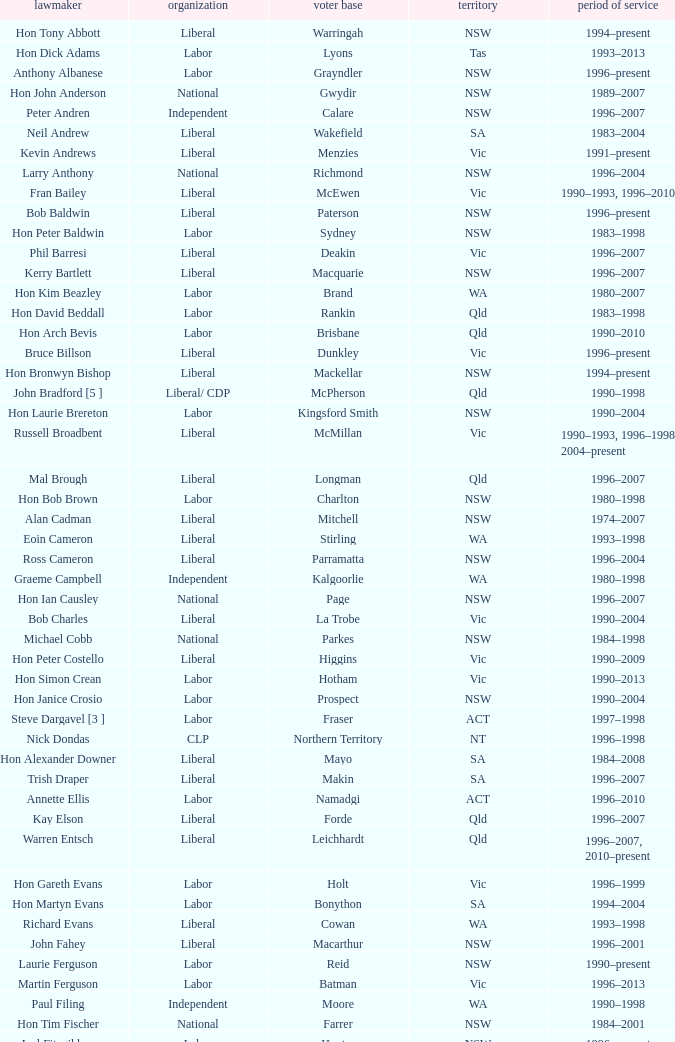Would you mind parsing the complete table? {'header': ['lawmaker', 'organization', 'voter base', 'territory', 'period of service'], 'rows': [['Hon Tony Abbott', 'Liberal', 'Warringah', 'NSW', '1994–present'], ['Hon Dick Adams', 'Labor', 'Lyons', 'Tas', '1993–2013'], ['Anthony Albanese', 'Labor', 'Grayndler', 'NSW', '1996–present'], ['Hon John Anderson', 'National', 'Gwydir', 'NSW', '1989–2007'], ['Peter Andren', 'Independent', 'Calare', 'NSW', '1996–2007'], ['Neil Andrew', 'Liberal', 'Wakefield', 'SA', '1983–2004'], ['Kevin Andrews', 'Liberal', 'Menzies', 'Vic', '1991–present'], ['Larry Anthony', 'National', 'Richmond', 'NSW', '1996–2004'], ['Fran Bailey', 'Liberal', 'McEwen', 'Vic', '1990–1993, 1996–2010'], ['Bob Baldwin', 'Liberal', 'Paterson', 'NSW', '1996–present'], ['Hon Peter Baldwin', 'Labor', 'Sydney', 'NSW', '1983–1998'], ['Phil Barresi', 'Liberal', 'Deakin', 'Vic', '1996–2007'], ['Kerry Bartlett', 'Liberal', 'Macquarie', 'NSW', '1996–2007'], ['Hon Kim Beazley', 'Labor', 'Brand', 'WA', '1980–2007'], ['Hon David Beddall', 'Labor', 'Rankin', 'Qld', '1983–1998'], ['Hon Arch Bevis', 'Labor', 'Brisbane', 'Qld', '1990–2010'], ['Bruce Billson', 'Liberal', 'Dunkley', 'Vic', '1996–present'], ['Hon Bronwyn Bishop', 'Liberal', 'Mackellar', 'NSW', '1994–present'], ['John Bradford [5 ]', 'Liberal/ CDP', 'McPherson', 'Qld', '1990–1998'], ['Hon Laurie Brereton', 'Labor', 'Kingsford Smith', 'NSW', '1990–2004'], ['Russell Broadbent', 'Liberal', 'McMillan', 'Vic', '1990–1993, 1996–1998 2004–present'], ['Mal Brough', 'Liberal', 'Longman', 'Qld', '1996–2007'], ['Hon Bob Brown', 'Labor', 'Charlton', 'NSW', '1980–1998'], ['Alan Cadman', 'Liberal', 'Mitchell', 'NSW', '1974–2007'], ['Eoin Cameron', 'Liberal', 'Stirling', 'WA', '1993–1998'], ['Ross Cameron', 'Liberal', 'Parramatta', 'NSW', '1996–2004'], ['Graeme Campbell', 'Independent', 'Kalgoorlie', 'WA', '1980–1998'], ['Hon Ian Causley', 'National', 'Page', 'NSW', '1996–2007'], ['Bob Charles', 'Liberal', 'La Trobe', 'Vic', '1990–2004'], ['Michael Cobb', 'National', 'Parkes', 'NSW', '1984–1998'], ['Hon Peter Costello', 'Liberal', 'Higgins', 'Vic', '1990–2009'], ['Hon Simon Crean', 'Labor', 'Hotham', 'Vic', '1990–2013'], ['Hon Janice Crosio', 'Labor', 'Prospect', 'NSW', '1990–2004'], ['Steve Dargavel [3 ]', 'Labor', 'Fraser', 'ACT', '1997–1998'], ['Nick Dondas', 'CLP', 'Northern Territory', 'NT', '1996–1998'], ['Hon Alexander Downer', 'Liberal', 'Mayo', 'SA', '1984–2008'], ['Trish Draper', 'Liberal', 'Makin', 'SA', '1996–2007'], ['Annette Ellis', 'Labor', 'Namadgi', 'ACT', '1996–2010'], ['Kay Elson', 'Liberal', 'Forde', 'Qld', '1996–2007'], ['Warren Entsch', 'Liberal', 'Leichhardt', 'Qld', '1996–2007, 2010–present'], ['Hon Gareth Evans', 'Labor', 'Holt', 'Vic', '1996–1999'], ['Hon Martyn Evans', 'Labor', 'Bonython', 'SA', '1994–2004'], ['Richard Evans', 'Liberal', 'Cowan', 'WA', '1993–1998'], ['John Fahey', 'Liberal', 'Macarthur', 'NSW', '1996–2001'], ['Laurie Ferguson', 'Labor', 'Reid', 'NSW', '1990–present'], ['Martin Ferguson', 'Labor', 'Batman', 'Vic', '1996–2013'], ['Paul Filing', 'Independent', 'Moore', 'WA', '1990–1998'], ['Hon Tim Fischer', 'National', 'Farrer', 'NSW', '1984–2001'], ['Joel Fitzgibbon', 'Labor', 'Hunter', 'NSW', '1996–present'], ['John Forrest', 'National', 'Mallee', 'Vic', '1993–2013'], ['Christine Gallus', 'Liberal', 'Hindmarsh', 'SA', '1990–2004'], ['Teresa Gambaro', 'Liberal', 'Petrie', 'Qld', '1996–2007, 2010–present'], ['Joanna Gash', 'Liberal', 'Gilmore', 'NSW', '1996–2013'], ['Petro Georgiou', 'Liberal', 'Kooyong', 'Vic', '1994–2010'], ['Ted Grace', 'Labor', 'Fowler', 'NSW', '1984–1998'], ['Elizabeth Grace', 'Liberal', 'Lilley', 'Qld', '1996–1998'], ['Alan Griffin', 'Labor', 'Bruce', 'Vic', '1993–present'], ['Bob Halverson', 'Liberal', 'Casey', 'Vic', '1984–1998'], ['Pauline Hanson [4 ]', 'Independent/ ONP', 'Oxley', 'Qld', '1996–1998'], ['Gary Hardgrave', 'Liberal', 'Moreton', 'Qld', '1996–2007'], ['Michael Hatton [1 ]', 'Labor', 'Blaxland', 'NSW', '1996–2007'], ['David Hawker', 'Liberal', 'Wannon', 'Vic', '1983–2010'], ['Noel Hicks', 'National', 'Riverina', 'NSW', '1980–1998'], ['Joe Hockey', 'Liberal', 'North Sydney', 'NSW', '1996–present'], ['Hon Clyde Holding', 'Labor', 'Melbourne Ports', 'Vic', '1977–1998'], ['Colin Hollis', 'Labor', 'Throsby', 'NSW', '1984–2001'], ['Hon John Howard', 'Liberal', 'Bennelong', 'NSW', '1974–2007'], ['Susan Jeanes', 'Liberal', 'Kingston', 'SA', '1996–1998'], ['Harry Jenkins', 'Labor', 'Scullin', 'Vic', '1986–2013'], ['Ricky Johnston', 'Liberal', 'Canning', 'WA', '1996–1998'], ['Hon Barry Jones', 'Labor', 'Lalor', 'Vic', '1977–1998'], ['Hon David Jull', 'Liberal', 'Fadden', 'Qld', '1975–1983, 1984–2007'], ['Hon Bob Katter', 'National', 'Kennedy', 'Qld', '1993–present'], ['Paul Keating [1 ]', 'Labor', 'Blaxland', 'NSW', '1969–1996'], ['De-Anne Kelly', 'National', 'Dawson', 'Qld', '1996–2007'], ['Jackie Kelly [2 ]', 'Liberal', 'Lindsay', 'NSW', '1996–2007'], ['Hon Dr David Kemp', 'Liberal', 'Goldstein', 'Vic', '1990–2004'], ['Hon Duncan Kerr', 'Labor', 'Denison', 'Tas', '1987–2010'], ['John Langmore [3 ]', 'Labor', 'Fraser', 'ACT', '1984–1997'], ['Mark Latham', 'Labor', 'Werriwa', 'NSW', '1994–2005'], ['Hon Dr Carmen Lawrence', 'Labor', 'Fremantle', 'WA', '1994–2007'], ['Hon Michael Lee', 'Labor', 'Dobell', 'NSW', '1984–2001'], ['Hon Lou Lieberman', 'Liberal', 'Indi', 'Vic', '1993–2001'], ['Peter Lindsay', 'Liberal', 'Herbert', 'Qld', '1996–2010'], ['Jim Lloyd', 'Liberal', 'Robertson', 'NSW', '1996–2007'], ['Stewart McArthur', 'Liberal', 'Corangamite', 'Vic', '1984–2007'], ['Robert McClelland', 'Labor', 'Barton', 'NSW', '1996–2013'], ['Graeme McDougall', 'Liberal', 'Griffith', 'Qld', '1996–1998'], ['Hon Peter McGauran', 'National', 'Gippsland', 'Vic', '1983–2008'], ['Hon Ian McLachlan', 'Liberal', 'Barker', 'SA', '1990–1998'], ['Hon Leo McLeay', 'Labor', 'Watson', 'NSW', '1979–2004'], ['Hon Bob McMullan', 'Labor', 'Canberra', 'ACT', '1996–2010'], ['Jenny Macklin', 'Labor', 'Jagajaga', 'Vic', '1996–present'], ['Paul Marek', 'National', 'Capricornia', 'Qld', '1996–1998'], ['Hon Stephen Martin', 'Labor', 'Cunningham', 'NSW', '1984–2002'], ['Daryl Melham', 'Labor', 'Banks', 'NSW', '1990–2013'], ['Hon Chris Miles', 'Liberal', 'Braddon', 'Tas', '1984–1998'], ['Hon John Moore', 'Liberal', 'Ryan', 'Qld', '1975–2001'], ['Allan Morris', 'Labor', 'Newcastle', 'NSW', '1983–2001'], ['Hon Peter Morris', 'Labor', 'Shortland', 'NSW', '1972–1998'], ['Frank Mossfield', 'Labor', 'Greenway', 'NSW', '1996–2004'], ['Hon Judi Moylan', 'Liberal', 'Pearce', 'WA', '1993–2013'], ['Stephen Mutch', 'Liberal', 'Cook', 'NSW', '1996–1998'], ['Gary Nairn', 'Liberal', 'Eden-Monaro', 'NSW', '1996–2007'], ['Garry Nehl', 'National', 'Cowper', 'NSW', '1984–2001'], ['Dr Brendan Nelson', 'Liberal', 'Bradfield', 'NSW', '1996–2009'], ['Paul Neville', 'National', 'Hinkler', 'Qld', '1993–2013'], ['Peter Nugent', 'Liberal', 'Aston', 'Vic', '1990–2001'], ["Gavan O'Connor", 'Labor', 'Corio', 'Vic', '1993–2007'], ["Hon Neil O'Keefe", 'Labor', 'Burke', 'Vic', '1984–2001'], ['Hon Roger Price', 'Labor', 'Chifley', 'NSW', '1984–2010'], ['Hon Geoff Prosser', 'Liberal', 'Forrest', 'WA', '1987–2007'], ['Christopher Pyne', 'Liberal', 'Sturt', 'SA', '1993–present'], ['Harry Quick', 'Labor', 'Franklin', 'Tas', '1993–2007'], ['Don Randall', 'Liberal', 'Swan', 'WA', '1996–1998, 2001–present'], ['Hon Bruce Reid', 'Liberal', 'Bendigo', 'Vic', '1990–1998'], ['Hon Peter Reith', 'Liberal', 'Flinders', 'Vic', '1982–1983, 1984–2001'], ['Allan Rocher', 'Independent', 'Curtin', 'WA', '1981–1998'], ['Michael Ronaldson', 'Liberal', 'Ballarat', 'Vic', '1990–2001'], ['Hon Philip Ruddock', 'Liberal', 'Berowra', 'NSW', '1973–present'], ['Rod Sawford', 'Labor', 'Adelaide', 'SA', '1988–2007'], ['Hon Bruce Scott', 'National', 'Maranoa', 'Qld', '1990–present'], ['Bob Sercombe', 'Labor', 'Maribyrnong', 'Vic', '1996–2007'], ['Hon John Sharp', 'National', 'Hume', 'NSW', '1984–1998'], ['Hon Ian Sinclair', 'National', 'New England', 'NSW', '1963–1998'], ['Peter Slipper', 'Liberal', 'Fisher', 'Qld', '1984–1987, 1993–2013'], ['Tony Smith', 'Liberal/Independent [7 ]', 'Dickson', 'Qld', '1996–1998'], ['Stephen Smith', 'Labor', 'Perth', 'WA', '1993–2013'], ['Hon Warwick Smith', 'Liberal', 'Bass', 'Tas', '1984–1993, 1996–1998'], ['Alex Somlyay', 'Liberal', 'Fairfax', 'Qld', '1990–2013'], ['Dr Andrew Southcott', 'Liberal', 'Boothby', 'SA', '1996–present'], ['Dr Sharman Stone', 'Liberal', 'Murray', 'Vic', '1996–present'], ['Kathy Sullivan', 'Liberal', 'Moncrieff', 'Qld', '1984–2001'], ['Lindsay Tanner', 'Labor', 'Melbourne', 'Vic', '1993–2010'], ['Bill Taylor', 'Liberal', 'Groom', 'Qld', '1988–1998'], ['Hon Andrew Theophanous', 'Labor', 'Calwell', 'Vic', '1980–2001'], ['Hon Andrew Thomson', 'Liberal', 'Wentworth', 'NSW', '1995–2001'], ['Kelvin Thomson', 'Labor', 'Wills', 'Vic', '1996–present'], ['Warren Truss', 'National', 'Wide Bay', 'Qld', '1990–present'], ['Wilson Tuckey', 'Liberal', "O'Connor", 'WA', '1980–2010'], ['Mark Vaile', 'National', 'Lyne', 'NSW', '1993–2008'], ['Danna Vale', 'Liberal', 'Hughes', 'NSW', '1996–2010'], ['Barry Wakelin', 'Liberal', 'Grey', 'SA', '1993–2007'], ['Andrea West', 'Liberal', 'Bowman', 'Qld', '1996–1998'], ['Hon Daryl Williams', 'Liberal', 'Tangney', 'WA', '1993–2004'], ['Hon Ralph Willis', 'Labor', 'Gellibrand', 'Vic', '1972–1998'], ['Greg Wilton', 'Labor', 'Isaacs', 'Vic', '1996–2000'], ['Hon Michael Wooldridge', 'Liberal', 'Casey', 'Vic', '1987–2001'], ['Trish Worth', 'Liberal', 'Adelaide', 'SA', '1996–2004'], ['Paul Zammit', 'Liberal/Independent [6 ]', 'Lowe', 'NSW', '1996–1998']]} In what state was the electorate fowler? NSW. 